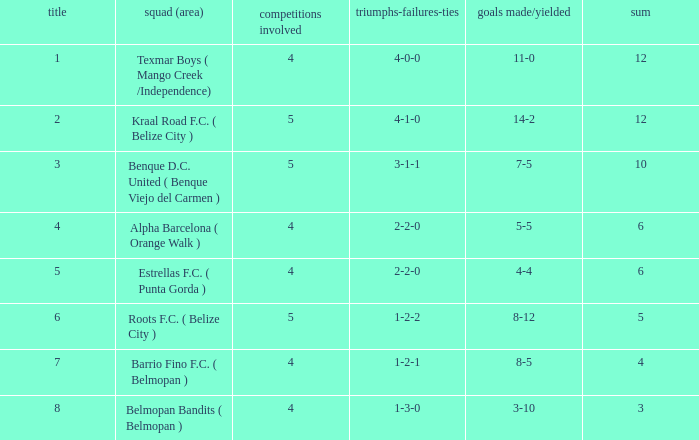Who is the the club (city/town) with goals for/against being 14-2 Kraal Road F.C. ( Belize City ). Can you parse all the data within this table? {'header': ['title', 'squad (area)', 'competitions involved', 'triumphs-failures-ties', 'goals made/yielded', 'sum'], 'rows': [['1', 'Texmar Boys ( Mango Creek /Independence)', '4', '4-0-0', '11-0', '12'], ['2', 'Kraal Road F.C. ( Belize City )', '5', '4-1-0', '14-2', '12'], ['3', 'Benque D.C. United ( Benque Viejo del Carmen )', '5', '3-1-1', '7-5', '10'], ['4', 'Alpha Barcelona ( Orange Walk )', '4', '2-2-0', '5-5', '6'], ['5', 'Estrellas F.C. ( Punta Gorda )', '4', '2-2-0', '4-4', '6'], ['6', 'Roots F.C. ( Belize City )', '5', '1-2-2', '8-12', '5'], ['7', 'Barrio Fino F.C. ( Belmopan )', '4', '1-2-1', '8-5', '4'], ['8', 'Belmopan Bandits ( Belmopan )', '4', '1-3-0', '3-10', '3']]} 